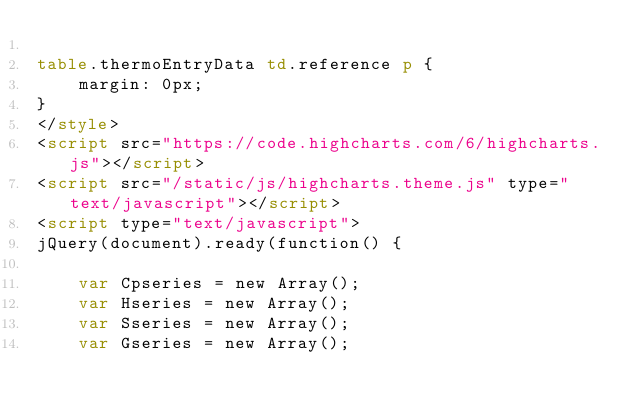Convert code to text. <code><loc_0><loc_0><loc_500><loc_500><_HTML_>
table.thermoEntryData td.reference p {
    margin: 0px;
}
</style>
<script src="https://code.highcharts.com/6/highcharts.js"></script>
<script src="/static/js/highcharts.theme.js" type="text/javascript"></script>
<script type="text/javascript">
jQuery(document).ready(function() {

    var Cpseries = new Array();
    var Hseries = new Array();
    var Sseries = new Array();
    var Gseries = new Array();

    </code> 